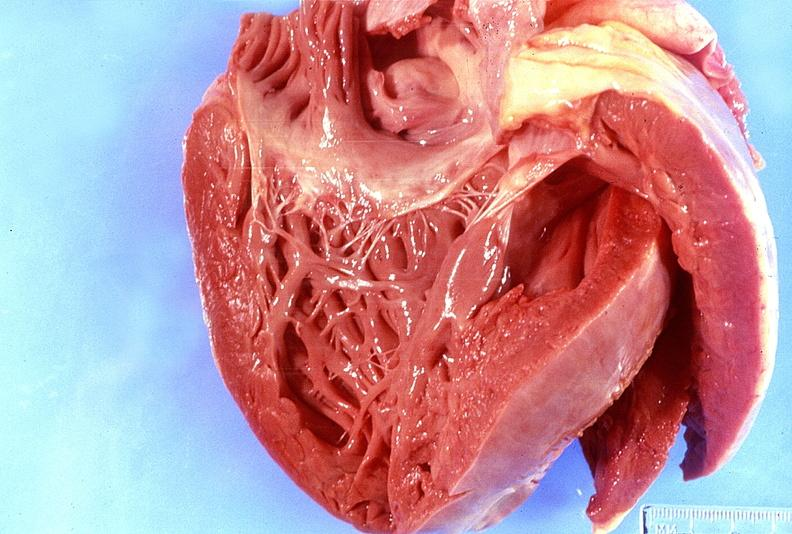what does this image show?
Answer the question using a single word or phrase. Normal tricuspid valve 